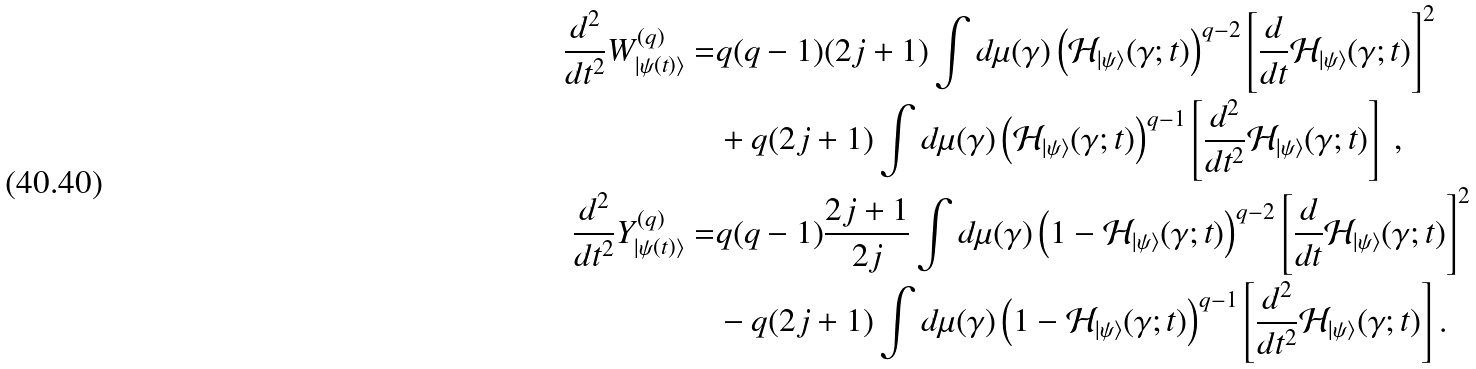<formula> <loc_0><loc_0><loc_500><loc_500>\frac { d ^ { 2 } } { d t ^ { 2 } } W ^ { ( q ) } _ { | \psi ( t ) \rangle } = & q ( q - 1 ) ( 2 j + 1 ) \int d \mu ( \gamma ) \left ( { \mathcal { H } } _ { | \psi \rangle } ( \gamma ; t ) \right ) ^ { q - 2 } \left [ \frac { d } { d t } { \mathcal { H } } _ { | \psi \rangle } ( \gamma ; t ) \right ] ^ { 2 } \\ & + q ( 2 j + 1 ) \int d \mu ( \gamma ) \left ( { \mathcal { H } } _ { | \psi \rangle } ( \gamma ; t ) \right ) ^ { q - 1 } \left [ \frac { d ^ { 2 } } { d t ^ { 2 } } { \mathcal { H } } _ { | \psi \rangle } ( \gamma ; t ) \right ] \ , \\ \frac { d ^ { 2 } } { d t ^ { 2 } } Y ^ { ( q ) } _ { | \psi ( t ) \rangle } = & q ( q - 1 ) \frac { 2 j + 1 } { 2 j } \int d \mu ( \gamma ) \left ( 1 - { \mathcal { H } } _ { | \psi \rangle } ( \gamma ; t ) \right ) ^ { q - 2 } \left [ \frac { d } { d t } { \mathcal { H } } _ { | \psi \rangle } ( \gamma ; t ) \right ] ^ { 2 } \\ & - q ( 2 j + 1 ) \int d \mu ( \gamma ) \left ( 1 - { \mathcal { H } } _ { | \psi \rangle } ( \gamma ; t ) \right ) ^ { q - 1 } \left [ \frac { d ^ { 2 } } { d t ^ { 2 } } { \mathcal { H } } _ { | \psi \rangle } ( \gamma ; t ) \right ] .</formula> 